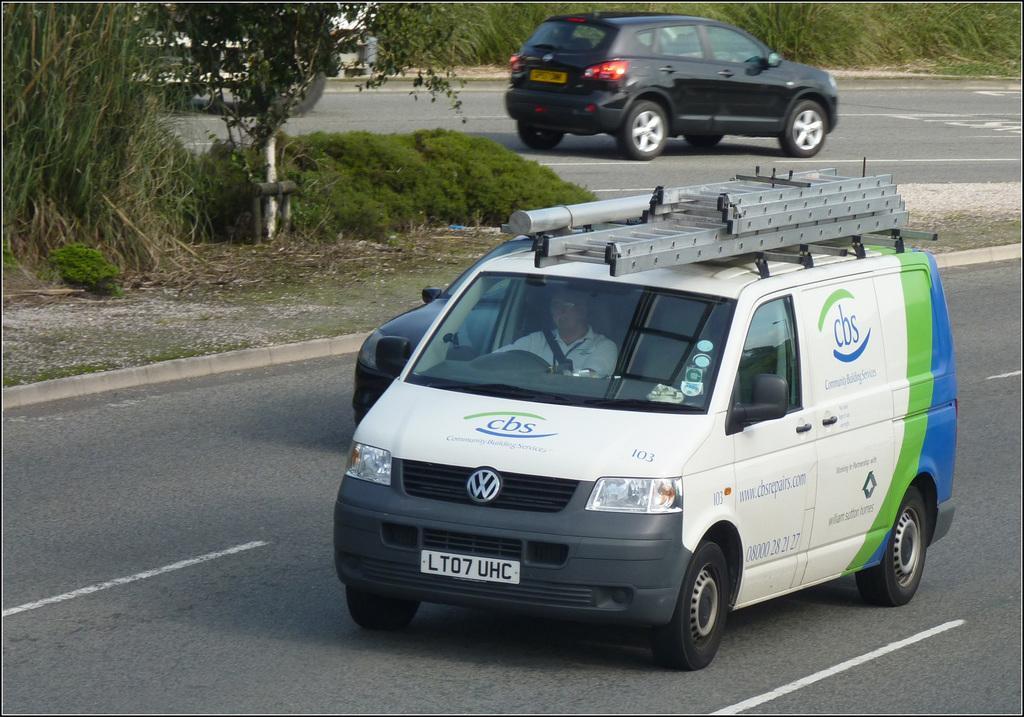Can you describe this image briefly? In this picture we can see a van and two cars traveling on the road, we can see a person inside the van, on the left side there is a tree, we can see grass here. 